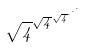<formula> <loc_0><loc_0><loc_500><loc_500>\sqrt { 4 } ^ { \sqrt { 4 } ^ { \sqrt { 4 } ^ { \cdot ^ { \cdot ^ { \cdot } } } } }</formula> 